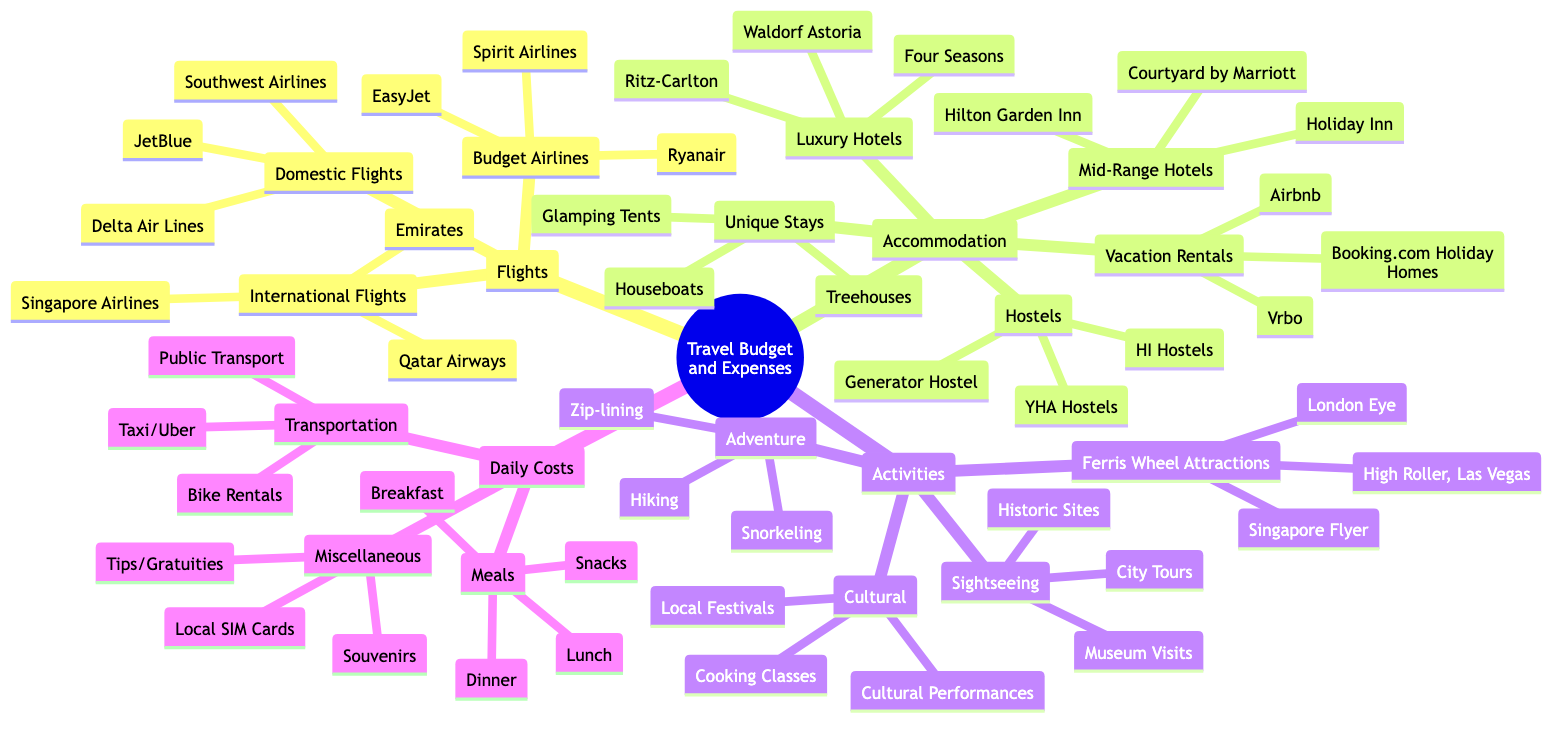What are the three categories of flights? The diagram lists three categories under "Flights": International Flights, Domestic Flights, and Budget Airlines.
Answer: International Flights, Domestic Flights, Budget Airlines How many types of accommodation are listed? The diagram includes five types of accommodation: Luxury Hotels, Mid-Range Hotels, Hostels, Vacation Rentals, and Unique Stays. Counting these gives a total of five types.
Answer: 5 What are two examples of Ferris Wheel attractions? Under the "Ferris Wheel Attractions" category, the diagram provides three examples: London Eye, Singapore Flyer, and High Roller, Las Vegas. The question asks for two examples, and the first two listed suffice.
Answer: London Eye, Singapore Flyer Which airline is a budget airline? The diagram names three budget airlines under "Budget Airlines": Ryanair, EasyJet, and Spirit Airlines. Any of these can be an acceptable answer as they all fit the criteria.
Answer: Ryanair Which category includes "Public Transport"? The diagram shows "Public Transport" as part of the "Transportation" category under "Daily Costs." This indicates that it falls under daily travel expenses.
Answer: Transportation What is the most expensive type of accommodation mentioned? Among the types of accommodation listed, "Luxury Hotels" typically represent the highest price category. Therefore, this is the logical choice based on standard pricing practices.
Answer: Luxury Hotels What are the two types of meals listed? The diagram specifies four meal types under "Meals": Breakfast, Lunch, Dinner, and Snacks. The question only requires two, so any two from the list can be mentioned.
Answer: Breakfast, Lunch Which activity involves 'Cooking'? The diagram lists "Cooking Classes" under the "Cultural" activities category. This shows that it's the specific activity related to cooking.
Answer: Cooking Classes How many unique stays are mentioned? The diagram lists three unique stays under "Unique Stays": Treehouses, Houseboats, and Glamping Tents. Counting these gives a total of three unique stay options.
Answer: 3 